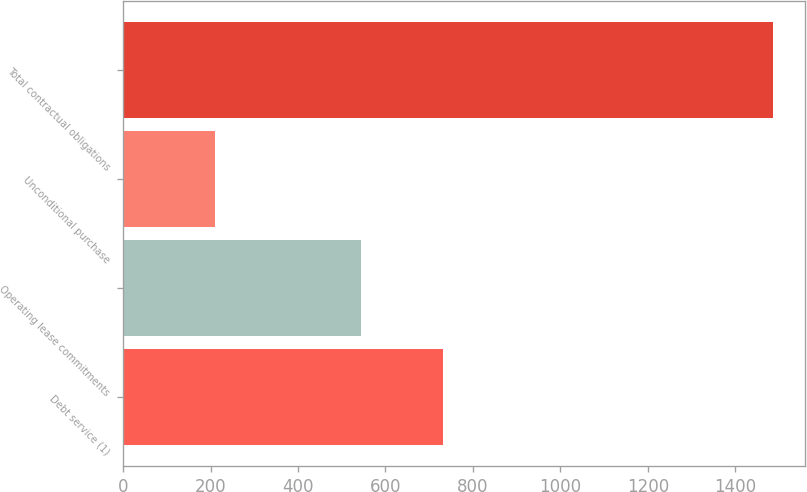<chart> <loc_0><loc_0><loc_500><loc_500><bar_chart><fcel>Debt service (1)<fcel>Operating lease commitments<fcel>Unconditional purchase<fcel>Total contractual obligations<nl><fcel>731<fcel>543.2<fcel>211<fcel>1485.2<nl></chart> 